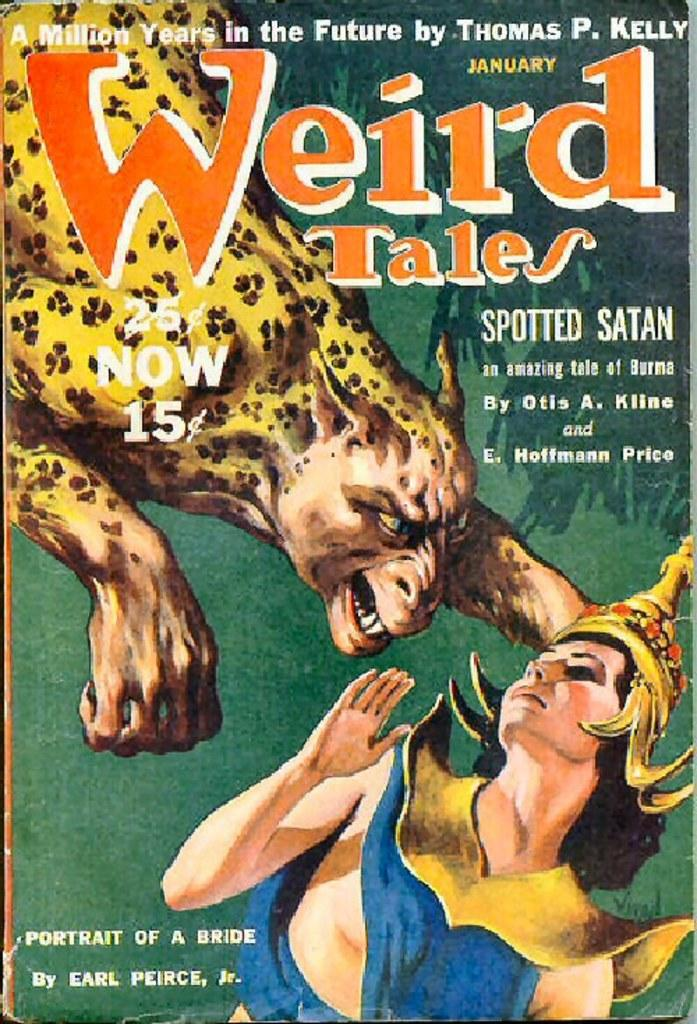<image>
Write a terse but informative summary of the picture. A page titled Weird Tales with the art being done by Earl Pierce. 